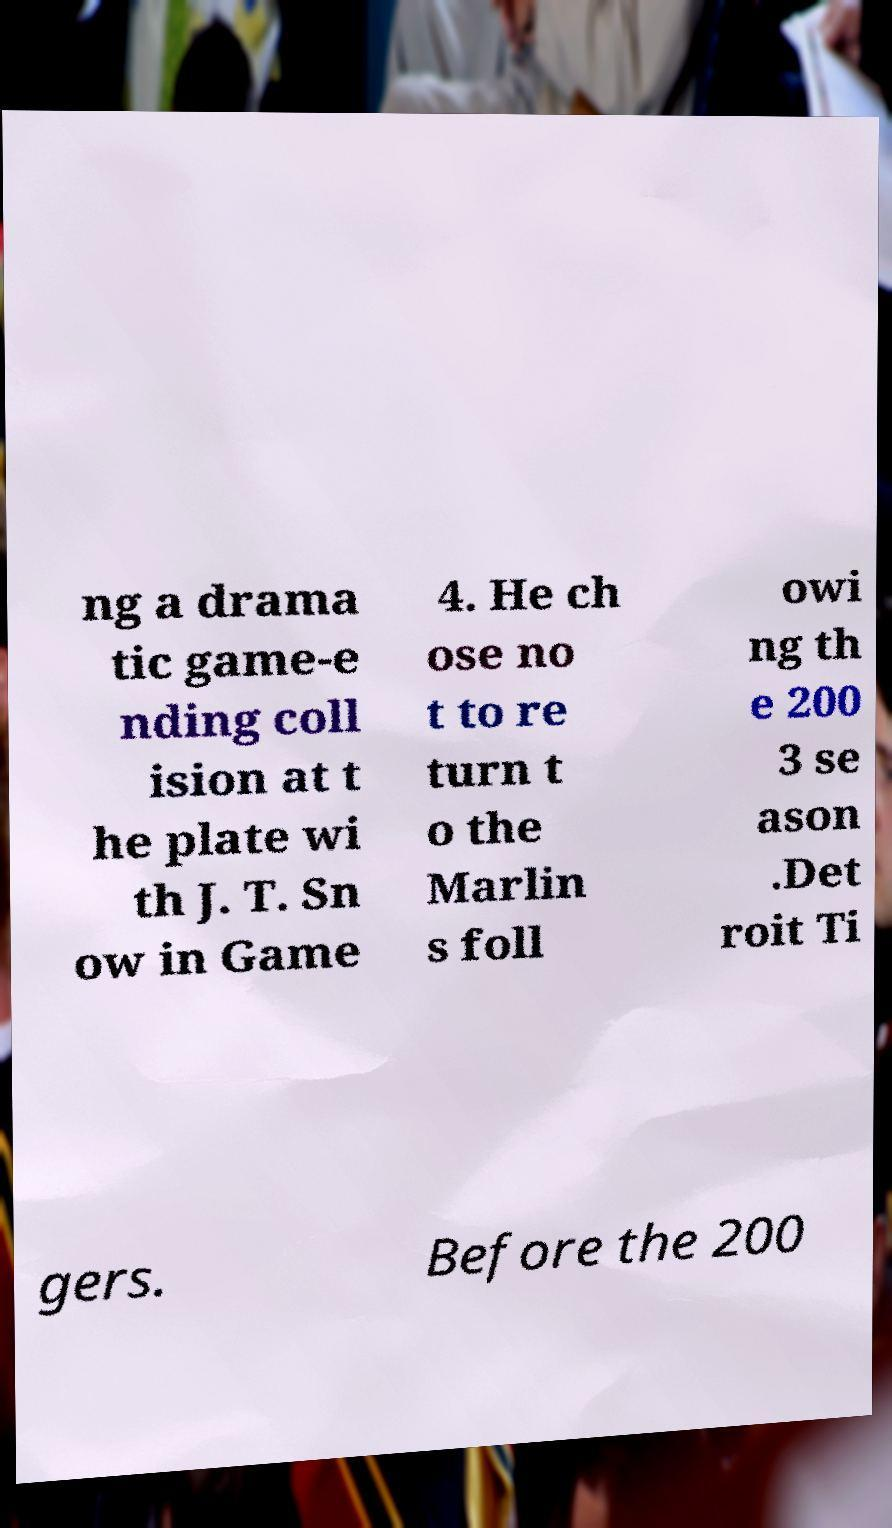What messages or text are displayed in this image? I need them in a readable, typed format. ng a drama tic game-e nding coll ision at t he plate wi th J. T. Sn ow in Game 4. He ch ose no t to re turn t o the Marlin s foll owi ng th e 200 3 se ason .Det roit Ti gers. Before the 200 